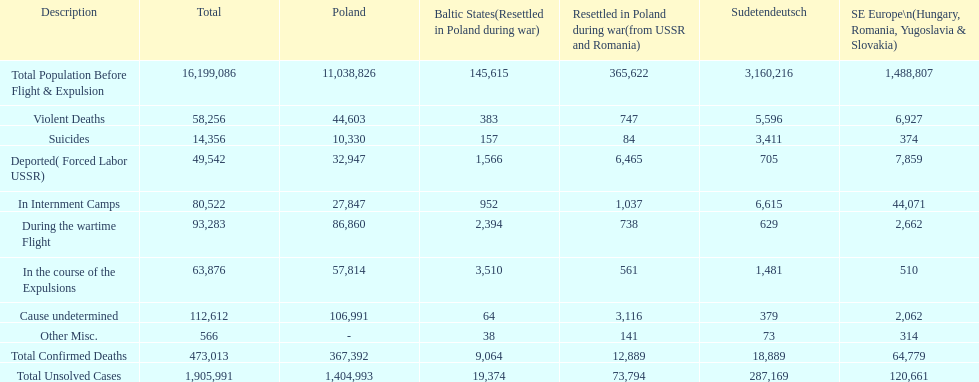What is the difference between suicides in poland and sudetendeutsch? 6919. 